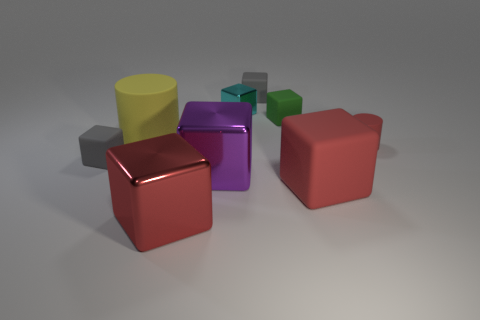Subtract all cyan blocks. How many blocks are left? 6 Subtract all small shiny cubes. How many cubes are left? 6 Subtract all purple blocks. Subtract all cyan balls. How many blocks are left? 6 Subtract all cubes. How many objects are left? 2 Add 1 tiny brown shiny objects. How many tiny brown shiny objects exist? 1 Subtract 0 cyan spheres. How many objects are left? 9 Subtract all large gray objects. Subtract all big shiny objects. How many objects are left? 7 Add 5 yellow cylinders. How many yellow cylinders are left? 6 